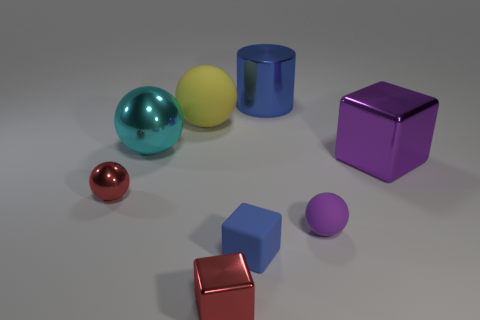How many small blue rubber objects have the same shape as the purple shiny thing?
Offer a very short reply. 1. What material is the yellow ball?
Your answer should be very brief. Rubber. Does the large metal cylinder have the same color as the tiny matte thing that is in front of the purple rubber ball?
Make the answer very short. Yes. What number of spheres are large blue shiny things or big purple metal objects?
Make the answer very short. 0. There is a shiny block in front of the purple metal object; what color is it?
Provide a short and direct response. Red. There is a large metallic object that is the same color as the tiny rubber ball; what shape is it?
Provide a succinct answer. Cube. What number of purple rubber balls are the same size as the blue rubber thing?
Provide a succinct answer. 1. There is a blue thing that is in front of the purple metal object; does it have the same shape as the red thing that is on the right side of the cyan ball?
Your response must be concise. Yes. What is the material of the small sphere that is to the right of the tiny red metal thing that is in front of the tiny matte object that is on the right side of the big blue metal thing?
Your response must be concise. Rubber. The purple shiny thing that is the same size as the yellow sphere is what shape?
Give a very brief answer. Cube. 